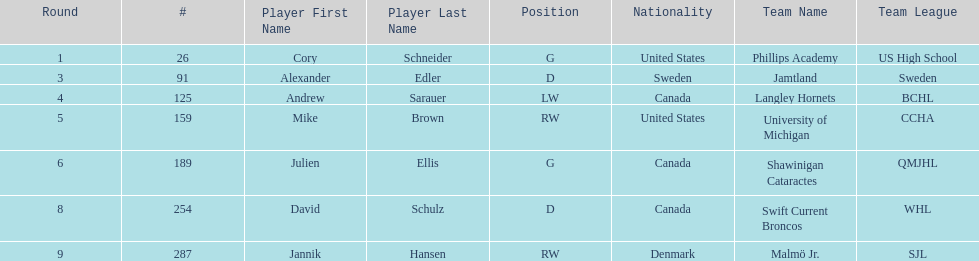Who is the only player to have denmark listed as their nationality? Jannik Hansen (RW). 